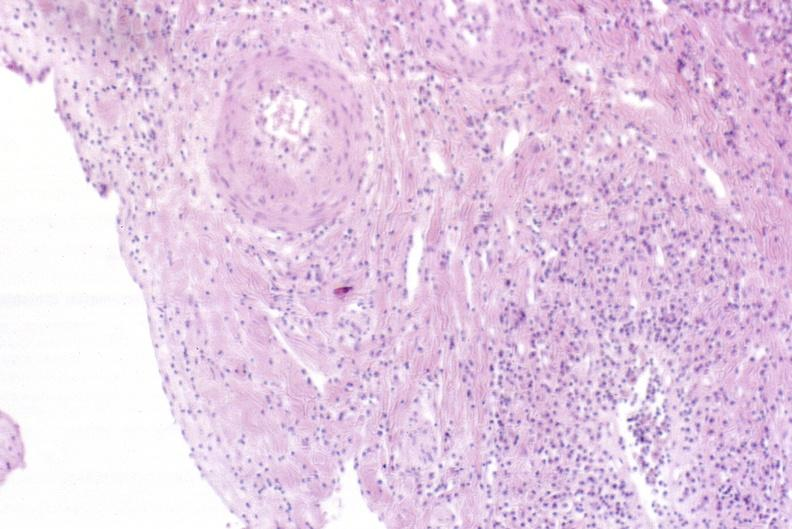does this image show severe acute rejection?
Answer the question using a single word or phrase. Yes 